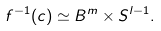<formula> <loc_0><loc_0><loc_500><loc_500>f ^ { - 1 } ( c ) \simeq B ^ { m } \times S ^ { l - 1 } .</formula> 